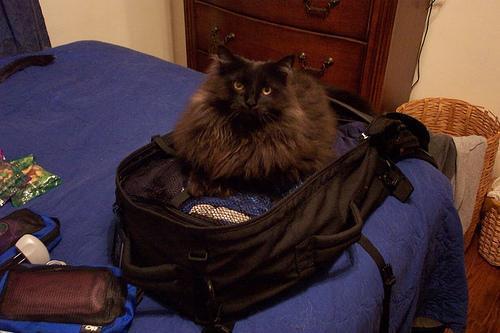How many people are on the bench?
Give a very brief answer. 0. 